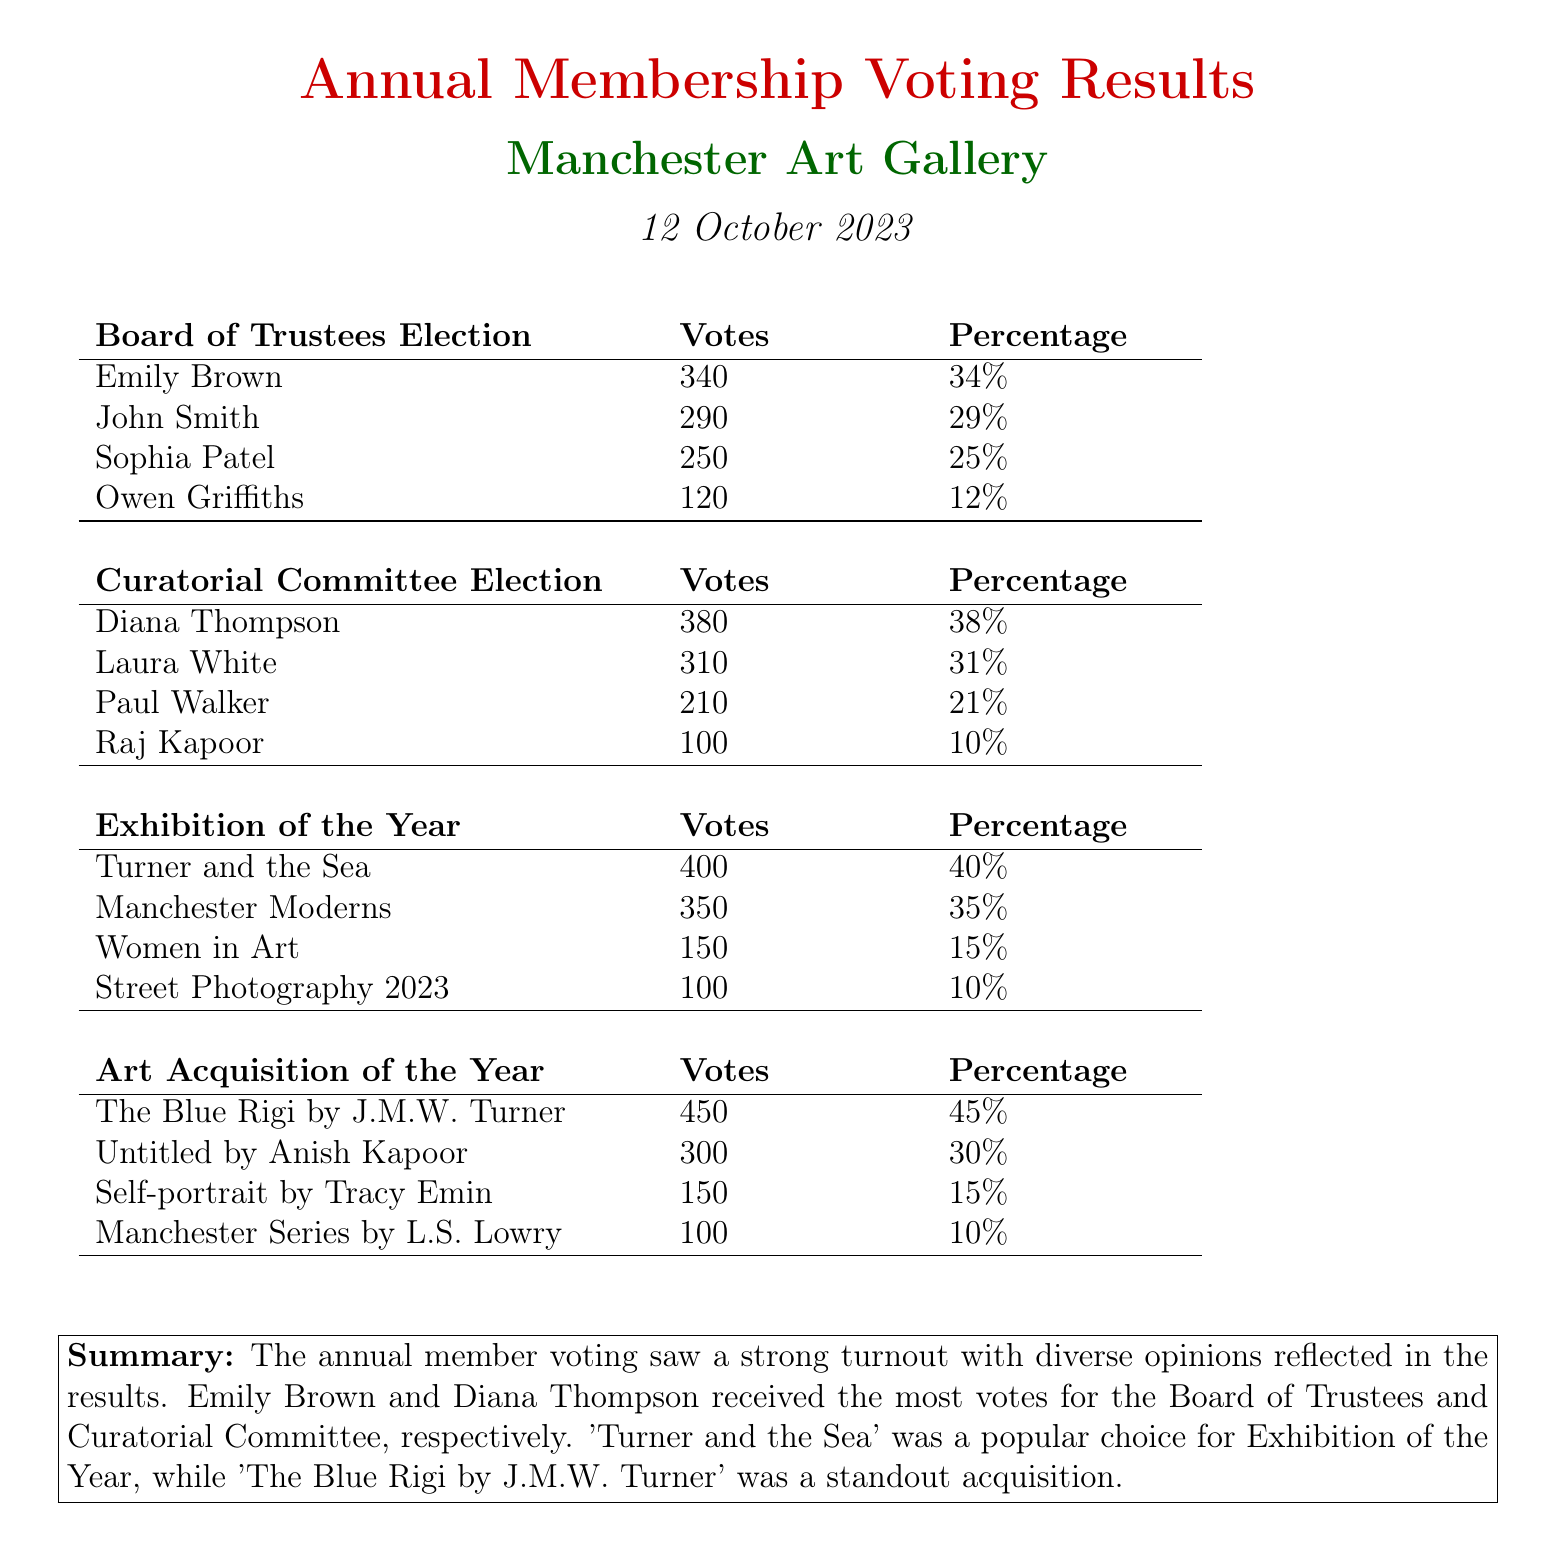what percentage of votes did Emily Brown receive? Emily Brown received 34% of the votes in the Board of Trustees election.
Answer: 34% who was elected from the Curatorial Committee? Diana Thompson received the most votes (380) in the Curatorial Committee election, making her the elected member.
Answer: Diana Thompson how many votes did the exhibition "Manchester Moderns" receive? "Manchester Moderns" received 350 votes in the Exhibition of the Year category.
Answer: 350 what is the title of the Art Acquisition of the Year winner? The title of the winning art acquisition is "The Blue Rigi by J.M.W. Turner."
Answer: The Blue Rigi by J.M.W. Turner how many candidates were there for the Board of Trustees election? There were four candidates listed for the Board of Trustees election.
Answer: four what was the total number of votes for the Exhibition of the Year? The total votes for the Exhibition of the Year can be calculated by summing the votes: 400 + 350 + 150 + 100 = 1000.
Answer: 1000 which art acquisition received the least votes? "Manchester Series by L.S. Lowry" received the least votes in the Art Acquisition of the Year category, with 100 votes.
Answer: Manchester Series by L.S. Lowry who received the second highest number of votes for the Board of Trustees? John Smith received the second highest number of votes with 290 in the Board of Trustees election.
Answer: John Smith which exhibition was favored the most according to the voting results? "Turner and the Sea" was favored the most, receiving 400 votes for Exhibition of the Year.
Answer: Turner and the Sea 